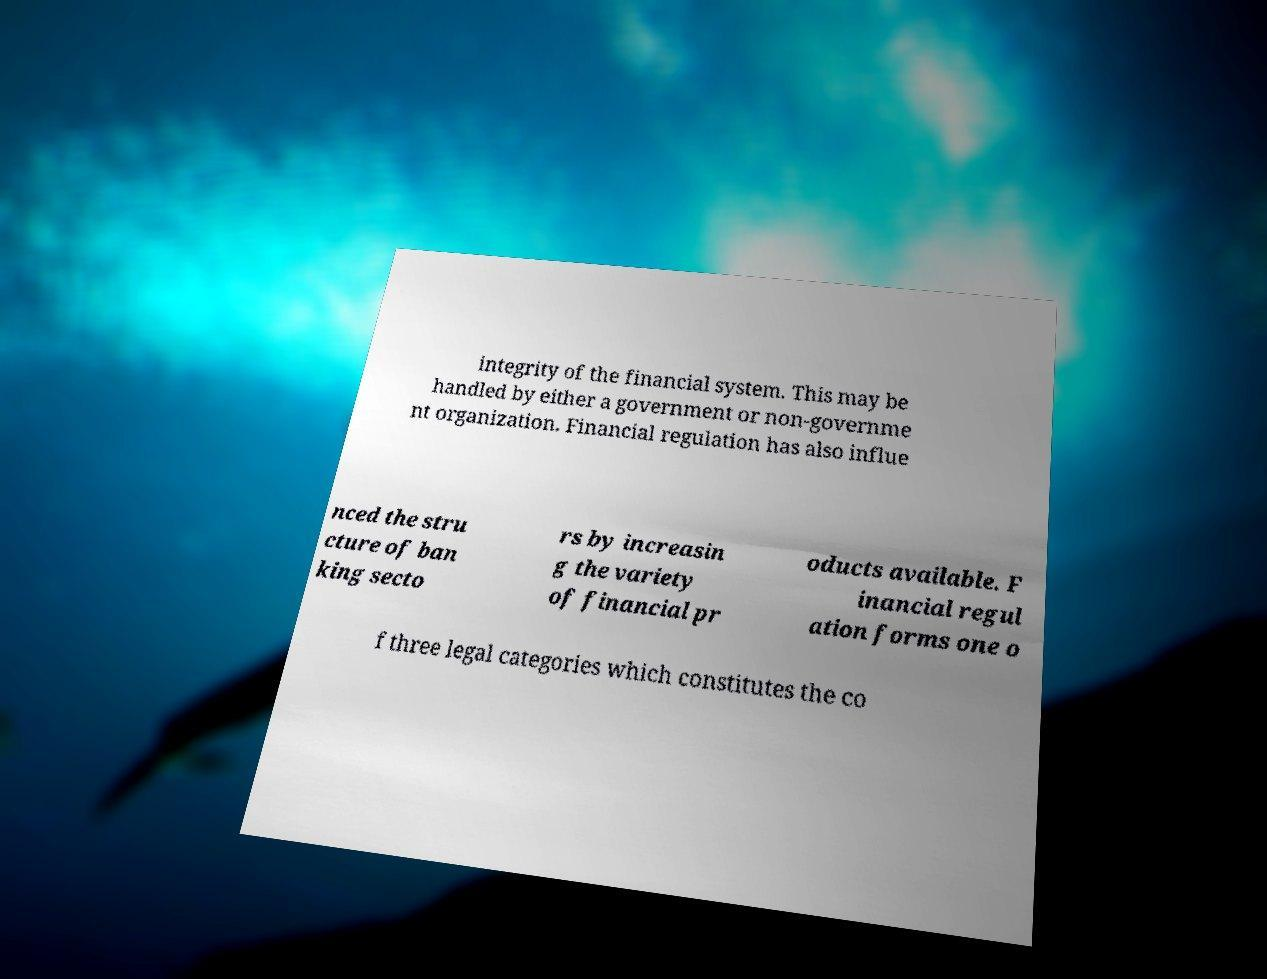There's text embedded in this image that I need extracted. Can you transcribe it verbatim? integrity of the financial system. This may be handled by either a government or non-governme nt organization. Financial regulation has also influe nced the stru cture of ban king secto rs by increasin g the variety of financial pr oducts available. F inancial regul ation forms one o f three legal categories which constitutes the co 